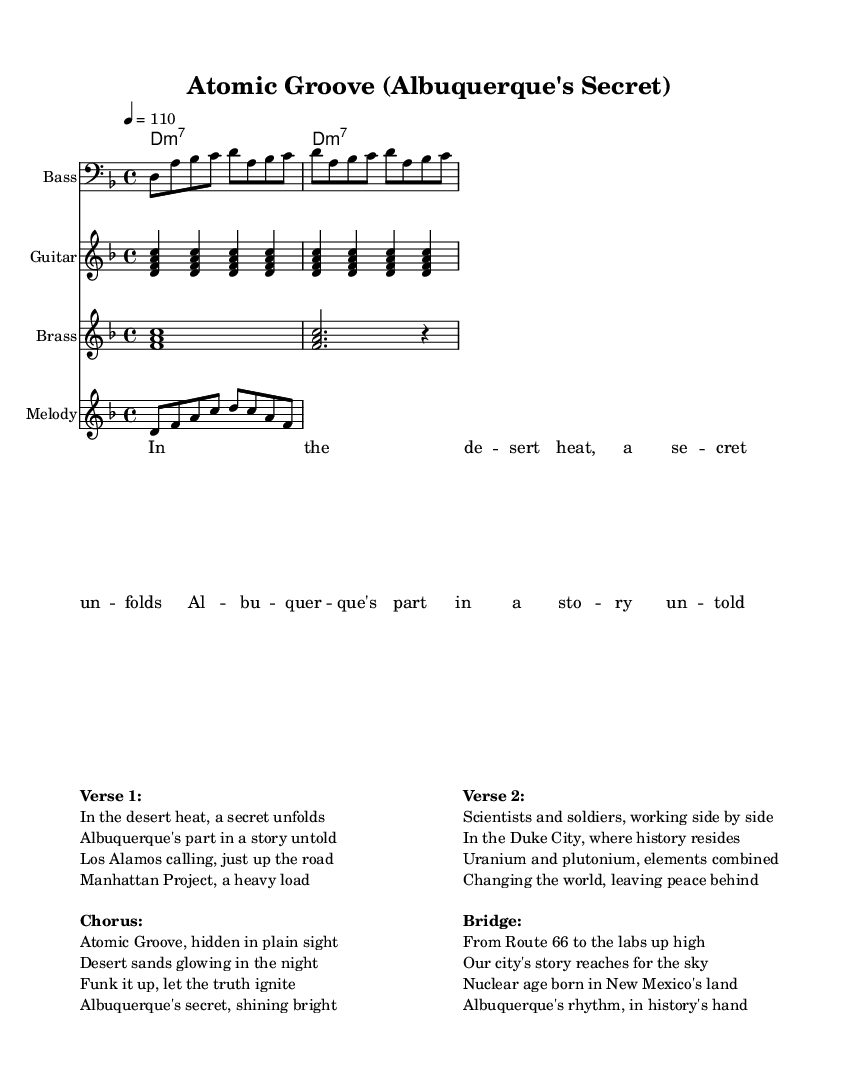What is the key signature of this music? The key signature is represented at the beginning of the score, indicating the key of D minor, which typically has one flat (B flat).
Answer: D minor What is the time signature of this music? The time signature appears at the beginning of the score, indicating the music is in 4/4 time, meaning there are four beats per measure.
Answer: 4/4 What is the tempo marking for this piece? The tempo marking is found at the beginning of the score, which shows that the piece should be played at a tempo of 110 beats per minute.
Answer: 110 What is the name of the piece? The title is prominently displayed at the top of the score, reading "Atomic Groove (Albuquerque's Secret)," indicating the name of the composition.
Answer: Atomic Groove (Albuquerque's Secret) How many verses are there in the lyrics? Upon examining the lyrics section, we can see that there are two distinct verses listed, which can be identified by the structure of the lyrics.
Answer: 2 What instruments are featured in the score? The instruments are listed at the beginning of each staff, and in this piece, there are four distinct sections: Bass, Guitar, Brass, and Melody.
Answer: Bass, Guitar, Brass, Melody What is the central theme explored in the lyrics? The lyrics describe historical connections to the Manhattan Project and Los Alamos, focusing on Albuquerque's hidden history related to atomic development.
Answer: Albuquerque's history 